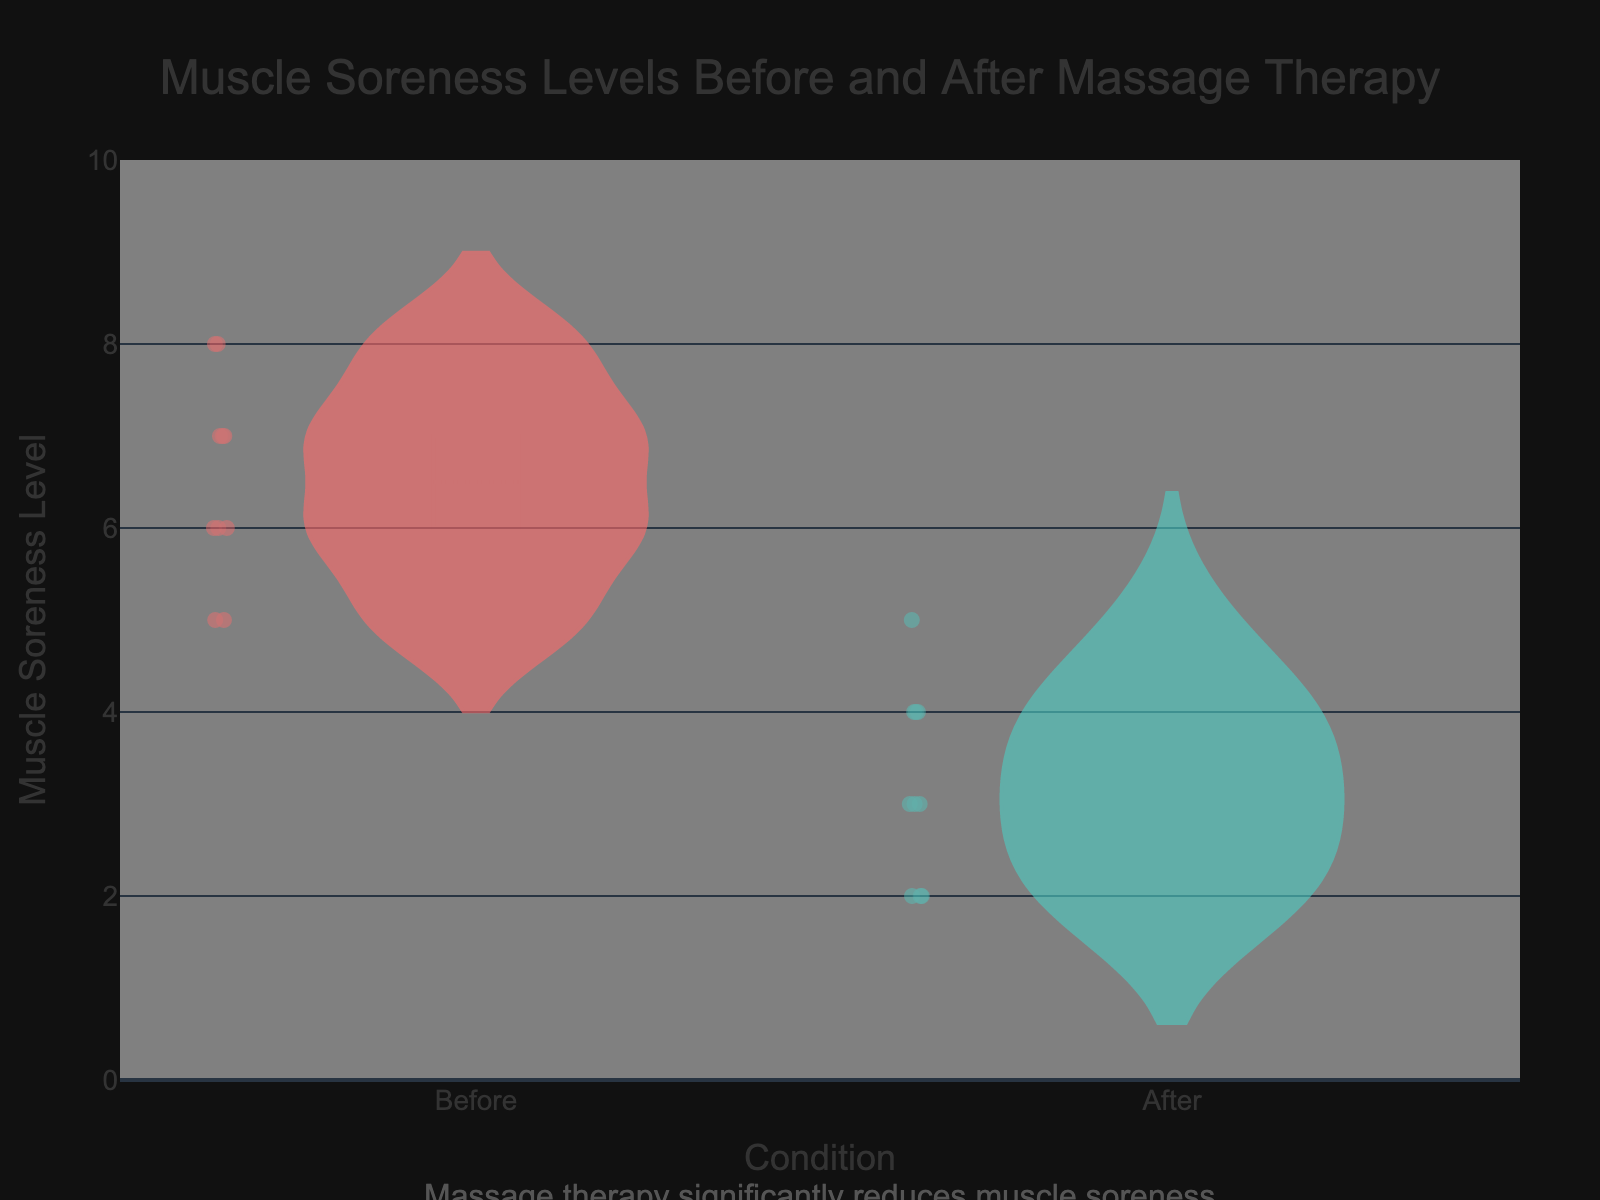What's the title of the plot? The title is displayed at the top center of the plot in a large font, specifying the subject of the visualization. The title reads “Muscle Soreness Levels Before and After Massage Therapy”.
Answer: Muscle Soreness Levels Before and After Massage Therapy How many data points are there for the "Before" condition? The "Before" violin plot displays the individual data points as markers. By counting all the markers, we determine the number of data points. There are 9 markers in the "Before" condition plot.
Answer: 9 What's the highest muscle soreness level in the "After" condition? The "After" violin plot, represented in teal color, shows the range of muscle soreness levels. The topmost point on this plot corresponds to the highest soreness level, which is 5.
Answer: 5 By how many units did the average muscle soreness level decrease after the massage therapy? The average muscle soreness level can be inferred from the mean lines on the violin plots. The mean level for "Before" is around 6.5, and for "After" is around 3. The decrease is the difference between these means: 6.5 - 3 = 3.5 units.
Answer: 3.5 In which condition is the variability of muscle soreness levels higher? Variability in a violin plot can be assessed by the spread of the plot. The "Before" condition plot appears wider and more spread out compared to the "After" condition, indicating greater variability in muscle soreness levels before massage therapy.
Answer: Before What is the minimum muscle soreness level observed across both conditions? The minimum muscle soreness level is the lowest point in either violin plot. The lowest point is 2, visible in both "Before" and "After" conditions.
Answer: 2 Did any participant report a muscle soreness level of 8 after the massage therapy? Reviewing the "After" violin plot, we look for the presence of data points at the soreness level of 8. There are no markers at level 8 in the "After" plot, suggesting no participants reported this level.
Answer: No What color is used to represent the "Before" condition data? The color representing the "Before" condition is visible from the appearance of the corresponding violin plot and markers. The color used is a shade of red.
Answer: Red What's the median muscle soreness level in the "Before" condition? The median is the middle value when the data is ordered. For the "Before" condition, the data points are: 5, 5, 6, 6, 6, 7, 7, 7, 8. The median value here is the 5th value, which is 6.
Answer: 6 Which condition has a higher number of unique muscle soreness levels reported? By listing the unique data points for each condition, we get 5 unique values (5, 6, 7, 8) for "Before" and 4 unique values (2, 3, 4, 5) for "After". The "Before" condition has more unique muscle soreness levels.
Answer: Before 